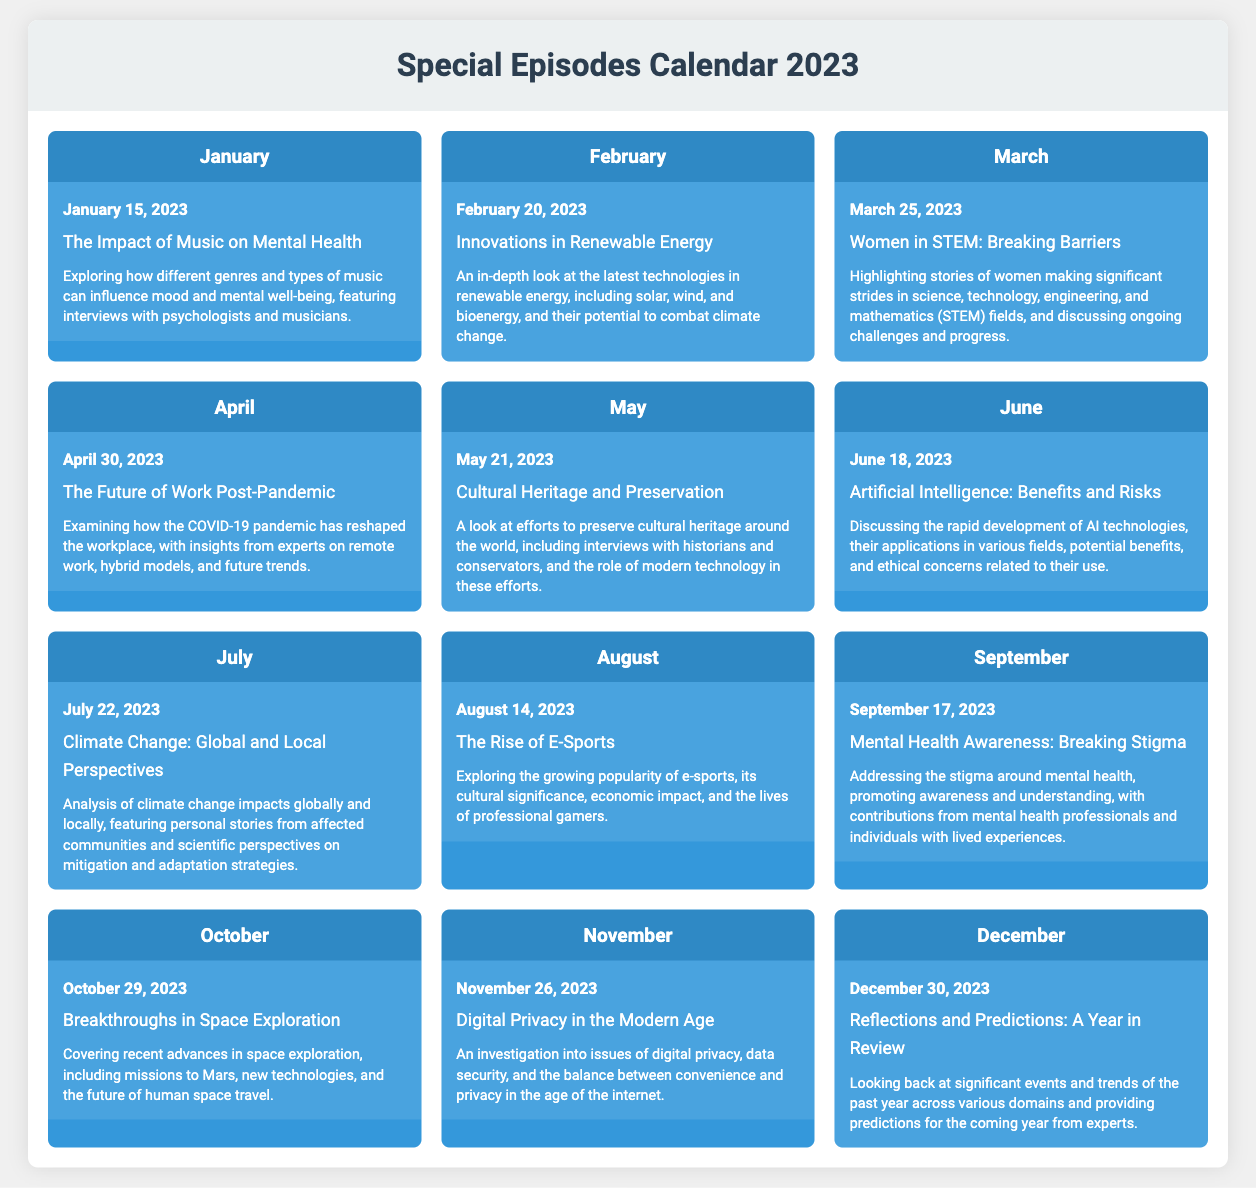What is the date of the episode "The Impact of Music on Mental Health"? The date mentioned for the episode "The Impact of Music on Mental Health" is January 15, 2023.
Answer: January 15, 2023 What is the title of the episode airing in June? The title of the episode airing in June is "Artificial Intelligence: Benefits and Risks."
Answer: Artificial Intelligence: Benefits and Risks How many episodes are there in total for 2023? The document lists twelve episodes for the year 2023.
Answer: Twelve Which month features the episode about digital privacy? The month featuring the episode about digital privacy is November.
Answer: November What is the theme of the episode on March 25, 2023? The theme of the episode on March 25, 2023, focuses on women in STEM and breaking barriers.
Answer: Women in STEM: Breaking Barriers Which episode discusses climate change? The episode that discusses climate change is titled "Climate Change: Global and Local Perspectives."
Answer: Climate Change: Global and Local Perspectives What is the last episode aired in December about? The last episode aired in December is about reflections on the past year and predictions for the future.
Answer: Reflections and Predictions: A Year in Review Which episode has a focus on mental health awareness? The episode focused on mental health awareness is titled "Mental Health Awareness: Breaking Stigma."
Answer: Mental Health Awareness: Breaking Stigma 